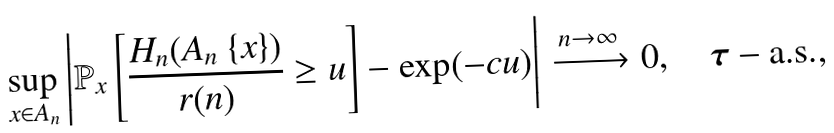Convert formula to latex. <formula><loc_0><loc_0><loc_500><loc_500>\sup _ { x \in A _ { n } } \left | \mathbb { P } _ { x } \left [ \frac { H _ { n } ( A _ { n } \ \{ x \} ) } { r ( n ) } \geq u \right ] - \exp ( - c u ) \right | \xrightarrow { n \to \infty } 0 , \quad \boldsymbol \tau - \text {a.s.} ,</formula> 